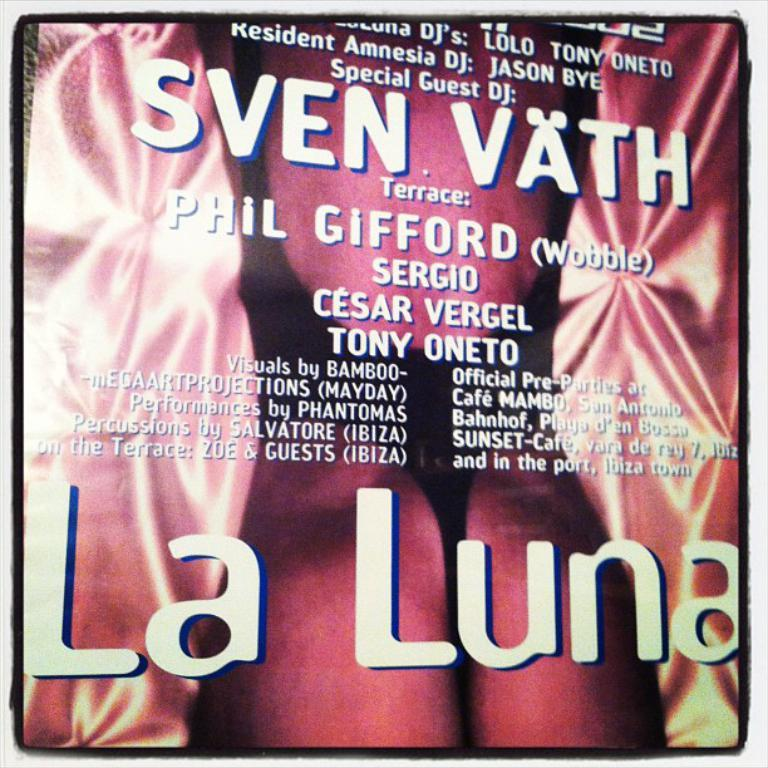<image>
Describe the image concisely. A sign promoting special guest DJ Sven Vath at La Luna. 